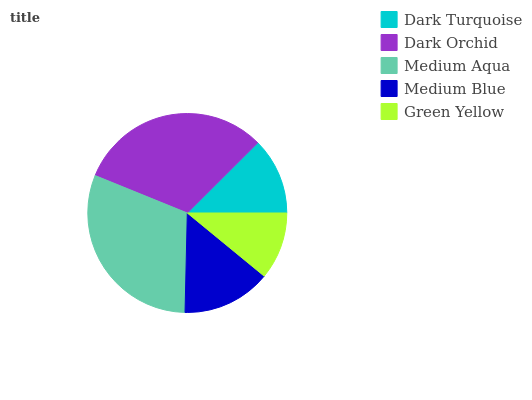Is Green Yellow the minimum?
Answer yes or no. Yes. Is Dark Orchid the maximum?
Answer yes or no. Yes. Is Medium Aqua the minimum?
Answer yes or no. No. Is Medium Aqua the maximum?
Answer yes or no. No. Is Dark Orchid greater than Medium Aqua?
Answer yes or no. Yes. Is Medium Aqua less than Dark Orchid?
Answer yes or no. Yes. Is Medium Aqua greater than Dark Orchid?
Answer yes or no. No. Is Dark Orchid less than Medium Aqua?
Answer yes or no. No. Is Medium Blue the high median?
Answer yes or no. Yes. Is Medium Blue the low median?
Answer yes or no. Yes. Is Dark Orchid the high median?
Answer yes or no. No. Is Medium Aqua the low median?
Answer yes or no. No. 